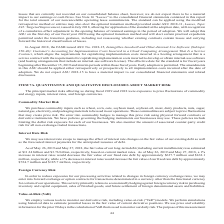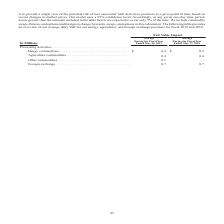According to Conagra Brands's financial document, How does the company estimate potential losses in the fair value of current derivative positions? Based on the financial document, the answer is perform simulations using historical data. Also, What does the company use in the calculation of VaR? price and volatility information for the prior 90 days. The document states: "air value of current derivative positions. We use price and volatility information for the prior 90 days in the calculation of VaR that is used to mon..." Also, What does the table provide for us? an overview of our average daily VaR for our energy, agriculture, and foreign exchange positions for fiscal 2019 and 2018. The document states: "in this calculation. The following table provides an overview of our average daily VaR for our energy, agriculture, and foreign exchange positions for..." Additionally, Which processing activity has the highest fair value impact during the fiscal year 2019? According to the financial document, Foreign Exchange. The relevant text states: "Foreign exchange . 0.7 0.7..." Also, can you calculate: What is the percentage change in the average fair value impact of energy commodities from 2018 to 2019? To answer this question, I need to perform calculations using the financial data. The calculation is: (0.4-0.2)/0.2 , which equals 100 (percentage). This is based on the information: "Energy commodities. . $ 0.4 $ 0.2 Energy commodities. . $ 0.4 $ 0.2..." The key data points involved are: 0.2, 0.4. Also, can you calculate: What is the average fair value impact of all processing activities in the fiscal year 2018? To answer this question, I need to perform calculations using the financial data. The calculation is: (0.2+0.4+0.7)/4 , which equals 0.33 (in millions). This is based on the information: "Energy commodities. . $ 0.4 $ 0.2 Foreign exchange . 0.7 0.7 Energy commodities. . $ 0.4 $ 0.2..." The key data points involved are: 0.2, 0.4, 0.7. 